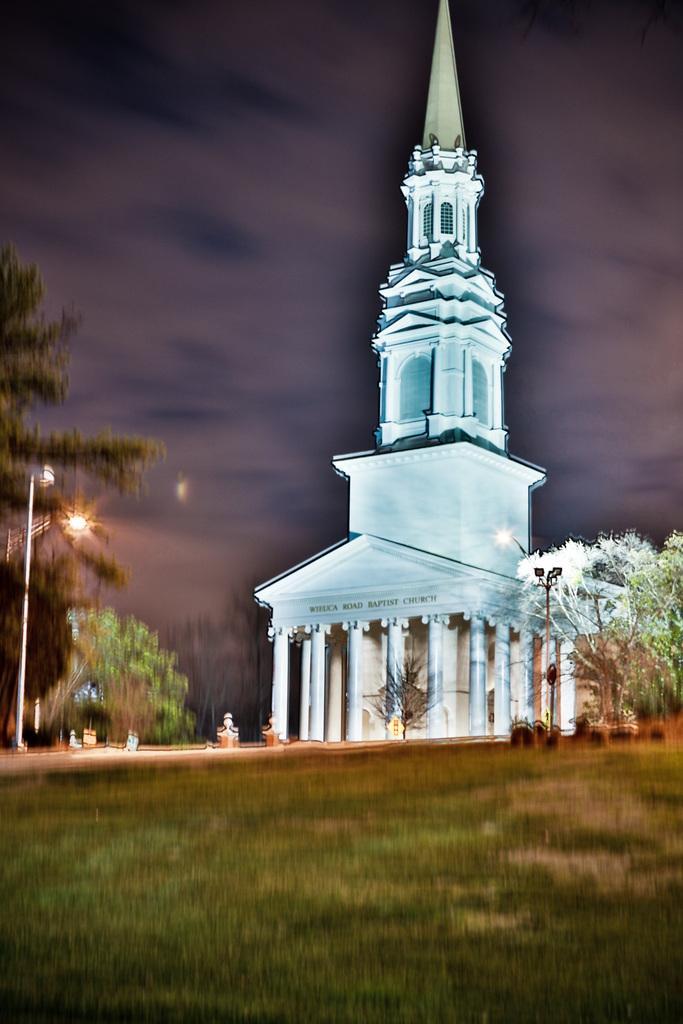Could you give a brief overview of what you see in this image? In this image there is a building. Left side there is a street light. There are trees on the grassland. Top of the image there is sky. 